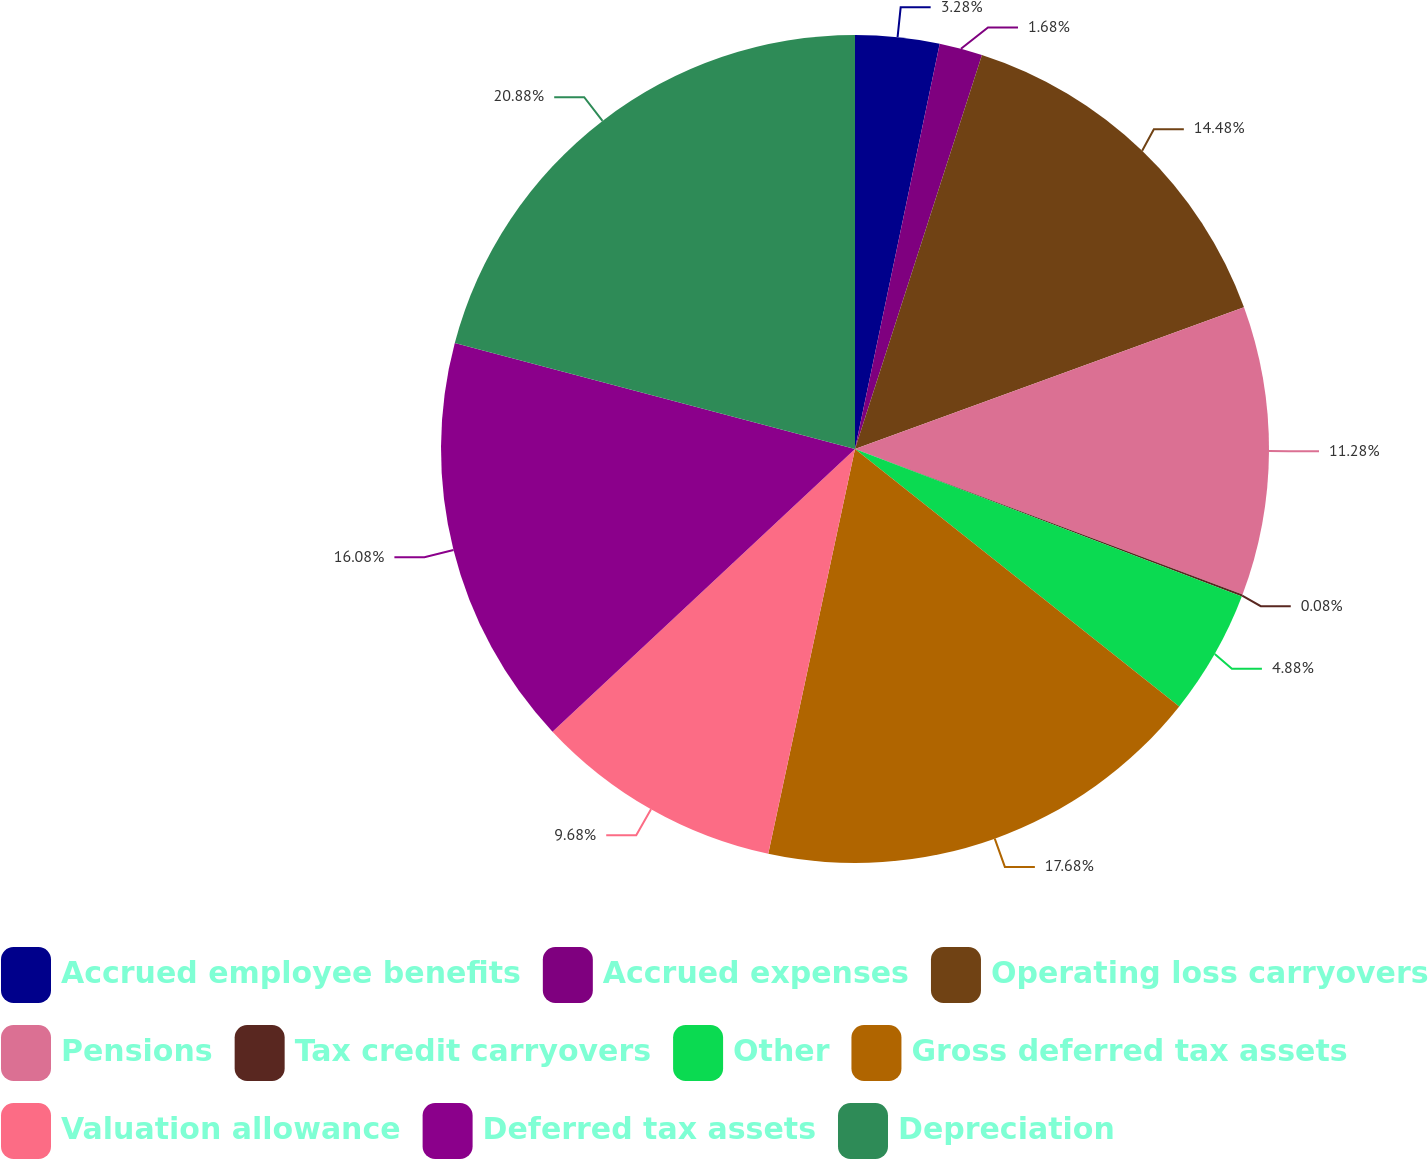Convert chart to OTSL. <chart><loc_0><loc_0><loc_500><loc_500><pie_chart><fcel>Accrued employee benefits<fcel>Accrued expenses<fcel>Operating loss carryovers<fcel>Pensions<fcel>Tax credit carryovers<fcel>Other<fcel>Gross deferred tax assets<fcel>Valuation allowance<fcel>Deferred tax assets<fcel>Depreciation<nl><fcel>3.28%<fcel>1.68%<fcel>14.48%<fcel>11.28%<fcel>0.08%<fcel>4.88%<fcel>17.68%<fcel>9.68%<fcel>16.08%<fcel>20.88%<nl></chart> 